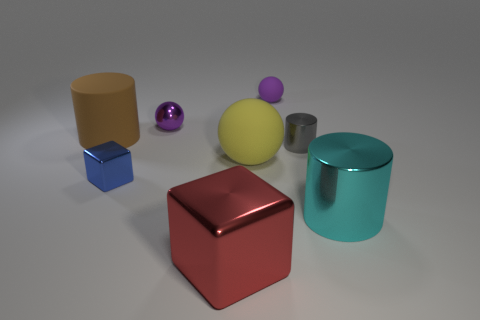What number of gray things are either large metallic blocks or metallic cylinders?
Ensure brevity in your answer.  1. Are there any purple matte spheres that have the same size as the cyan metallic cylinder?
Your response must be concise. No. How many large blue matte balls are there?
Offer a terse response. 0. How many small things are brown shiny spheres or yellow things?
Your answer should be compact. 0. What is the color of the large shiny thing on the right side of the purple sphere that is to the right of the object in front of the large cyan metal thing?
Give a very brief answer. Cyan. What number of other things are the same color as the big shiny cylinder?
Give a very brief answer. 0. What number of metallic objects are either small purple objects or cylinders?
Offer a terse response. 3. Does the large thing that is behind the large yellow ball have the same color as the metal block to the left of the red metal block?
Make the answer very short. No. Is there any other thing that has the same material as the gray cylinder?
Make the answer very short. Yes. What is the size of the cyan object that is the same shape as the large brown thing?
Provide a succinct answer. Large. 